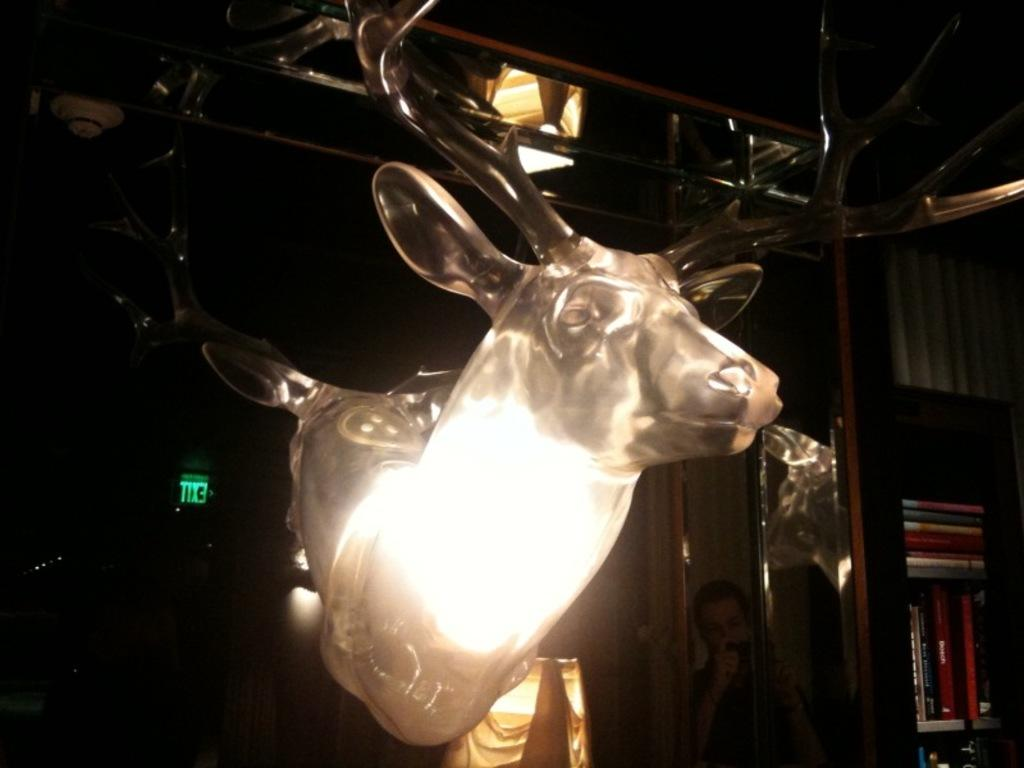What is the main subject of the image? There is a statue of a deer in the image. Where is the statue located? The statue is inside a building. What else can be seen on the right side of the image? There is a book rack on the right side of the image. How many ladybugs are crawling on the statue in the image? There are no ladybugs present on the statue in the image. 